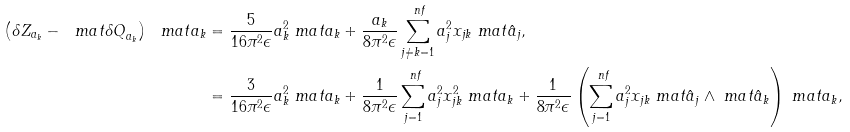<formula> <loc_0><loc_0><loc_500><loc_500>\left ( \delta Z _ { a _ { k } } - \ m a t { \delta Q } _ { a _ { k } } \right ) \ m a t { a } _ { k } & = \frac { 5 } { 1 6 \pi ^ { 2 } \epsilon } a _ { k } ^ { 2 } \ m a t { a } _ { k } + \frac { a _ { k } } { 8 \pi ^ { 2 } \epsilon } \sum _ { j \neq k = 1 } ^ { \ n f } a _ { j } ^ { 2 } x _ { j k } \ m a t { \hat { a } } _ { j } , \\ & = \frac { 3 } { 1 6 \pi ^ { 2 } \epsilon } a _ { k } ^ { 2 } \ m a t { a } _ { k } + \frac { 1 } { 8 \pi ^ { 2 } \epsilon } \sum _ { j = 1 } ^ { \ n f } a _ { j } ^ { 2 } x _ { j k } ^ { 2 } \ m a t { a } _ { k } + \frac { 1 } { 8 \pi ^ { 2 } \epsilon } \left ( \sum _ { j = 1 } ^ { \ n f } a _ { j } ^ { 2 } x _ { j k } \ m a t { \hat { a } } _ { j } \wedge \ m a t { \hat { a } } _ { k } \right ) \ m a t { a } _ { k } ,</formula> 